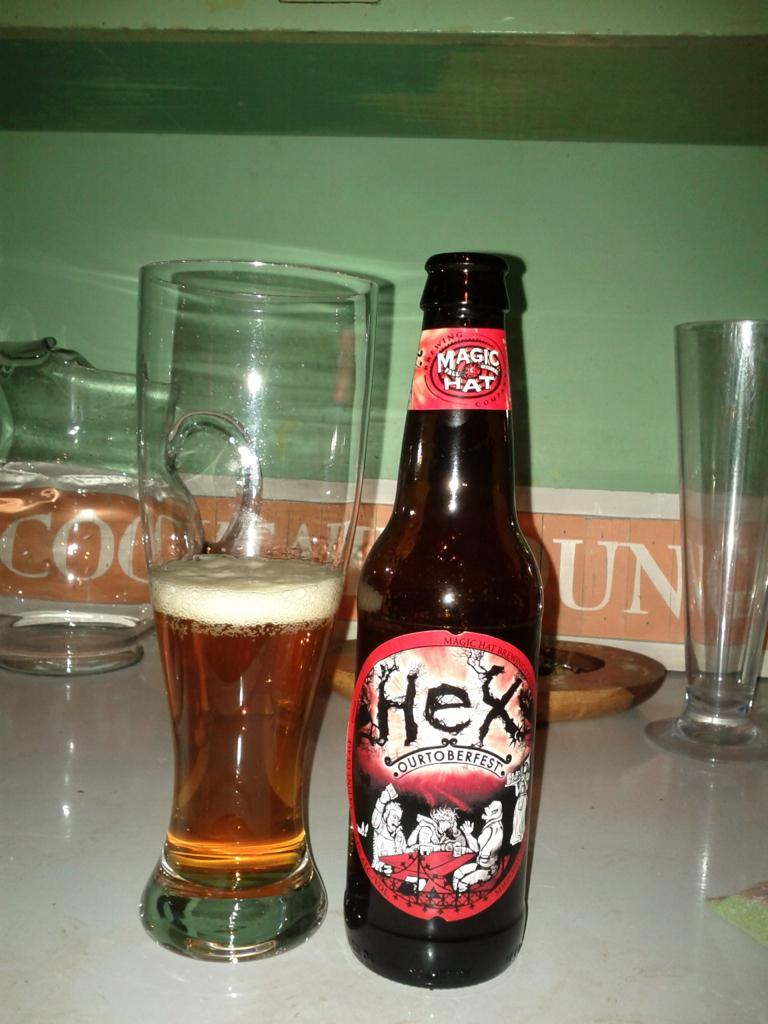<image>
Provide a brief description of the given image. a beer bottle with the word Hex on it next to a glass 